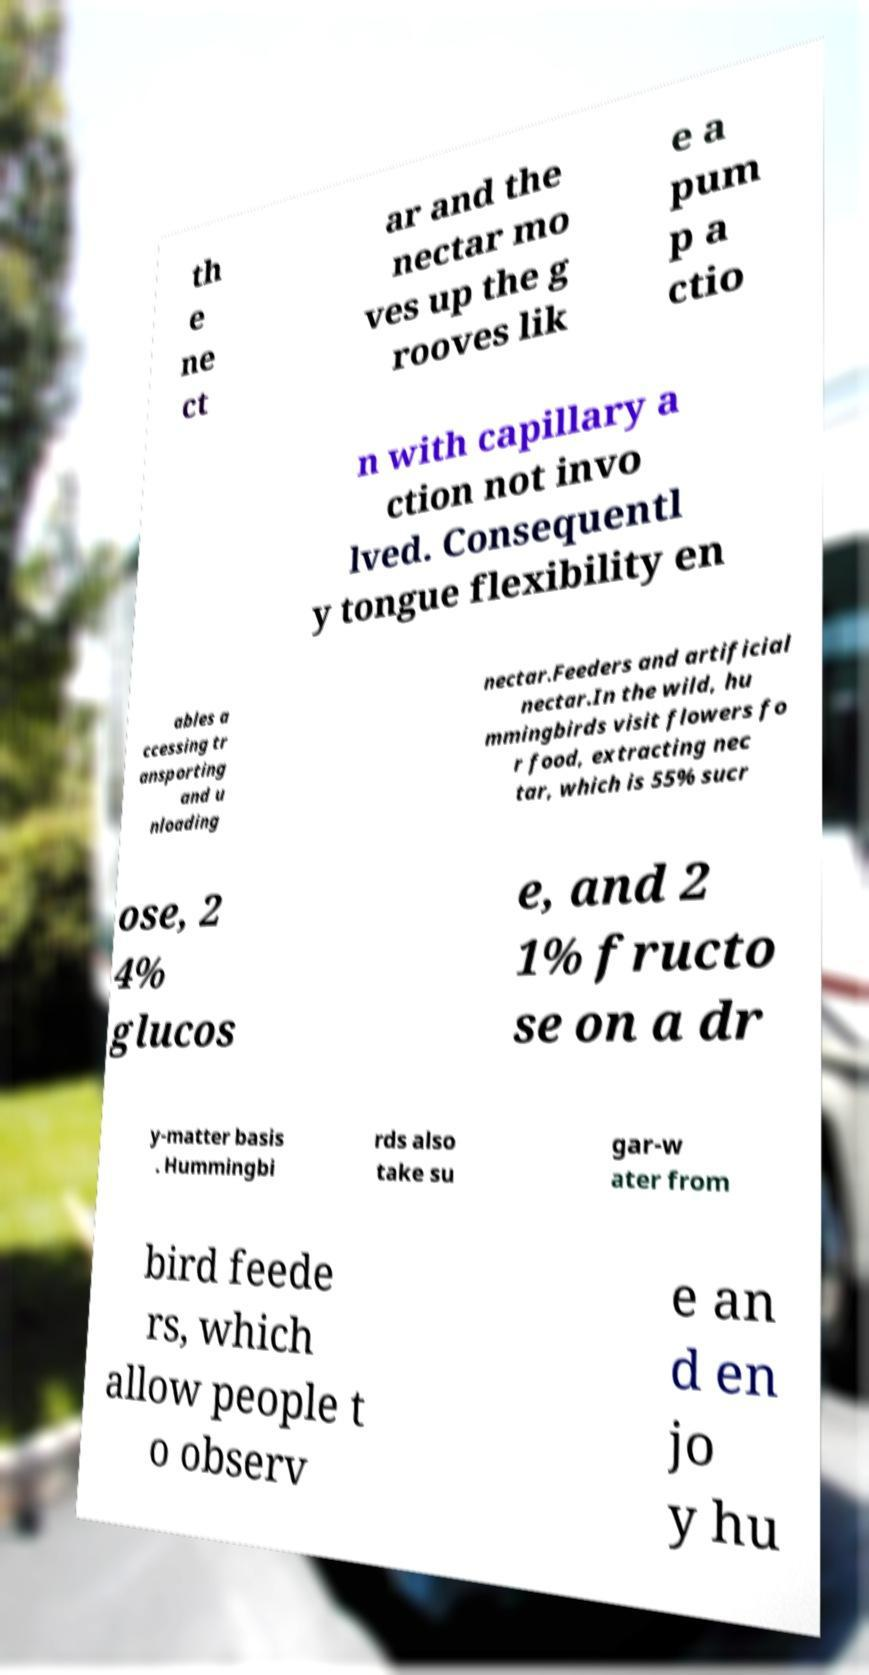Could you extract and type out the text from this image? th e ne ct ar and the nectar mo ves up the g rooves lik e a pum p a ctio n with capillary a ction not invo lved. Consequentl y tongue flexibility en ables a ccessing tr ansporting and u nloading nectar.Feeders and artificial nectar.In the wild, hu mmingbirds visit flowers fo r food, extracting nec tar, which is 55% sucr ose, 2 4% glucos e, and 2 1% fructo se on a dr y-matter basis . Hummingbi rds also take su gar-w ater from bird feede rs, which allow people t o observ e an d en jo y hu 